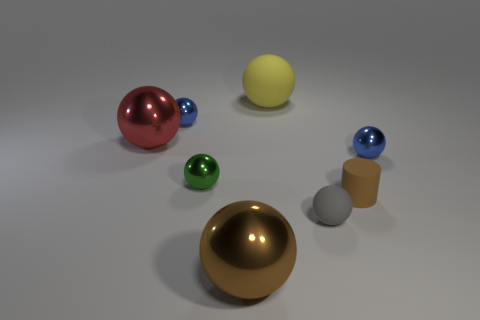Subtract all gray balls. How many balls are left? 6 Subtract all large balls. How many balls are left? 4 Subtract all red blocks. How many brown balls are left? 1 Add 8 small brown things. How many small brown things are left? 9 Add 6 red spheres. How many red spheres exist? 7 Add 2 red metallic cubes. How many objects exist? 10 Subtract 0 purple cylinders. How many objects are left? 8 Subtract all spheres. How many objects are left? 1 Subtract 1 cylinders. How many cylinders are left? 0 Subtract all purple cylinders. Subtract all blue cubes. How many cylinders are left? 1 